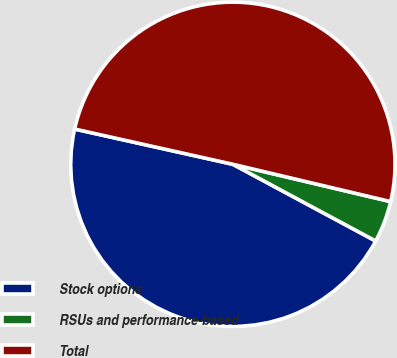Convert chart to OTSL. <chart><loc_0><loc_0><loc_500><loc_500><pie_chart><fcel>Stock options<fcel>RSUs and performance-based<fcel>Total<nl><fcel>45.64%<fcel>4.15%<fcel>50.21%<nl></chart> 